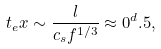Convert formula to latex. <formula><loc_0><loc_0><loc_500><loc_500>t _ { e } x \sim \frac { l } { c _ { s } f ^ { 1 / 3 } } \approx 0 ^ { d } . 5 ,</formula> 